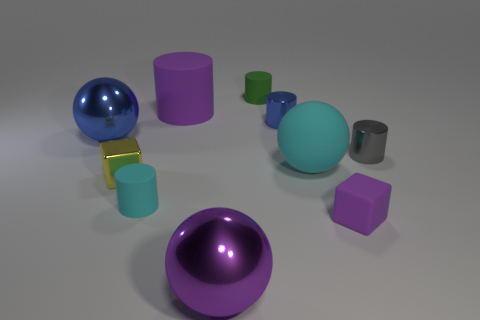Subtract 2 cylinders. How many cylinders are left? 3 Subtract all cyan cylinders. How many cylinders are left? 4 Subtract all gray cylinders. How many cylinders are left? 4 Subtract all yellow cylinders. Subtract all purple spheres. How many cylinders are left? 5 Subtract all spheres. How many objects are left? 7 Subtract all small purple matte spheres. Subtract all small gray metal things. How many objects are left? 9 Add 5 purple objects. How many purple objects are left? 8 Add 2 blocks. How many blocks exist? 4 Subtract 0 gray balls. How many objects are left? 10 